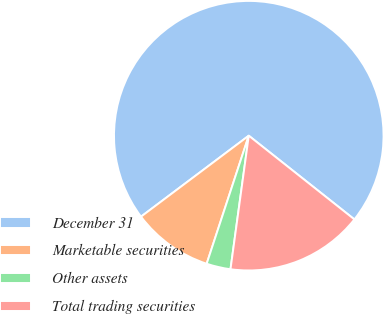Convert chart to OTSL. <chart><loc_0><loc_0><loc_500><loc_500><pie_chart><fcel>December 31<fcel>Marketable securities<fcel>Other assets<fcel>Total trading securities<nl><fcel>70.92%<fcel>9.69%<fcel>2.89%<fcel>16.5%<nl></chart> 